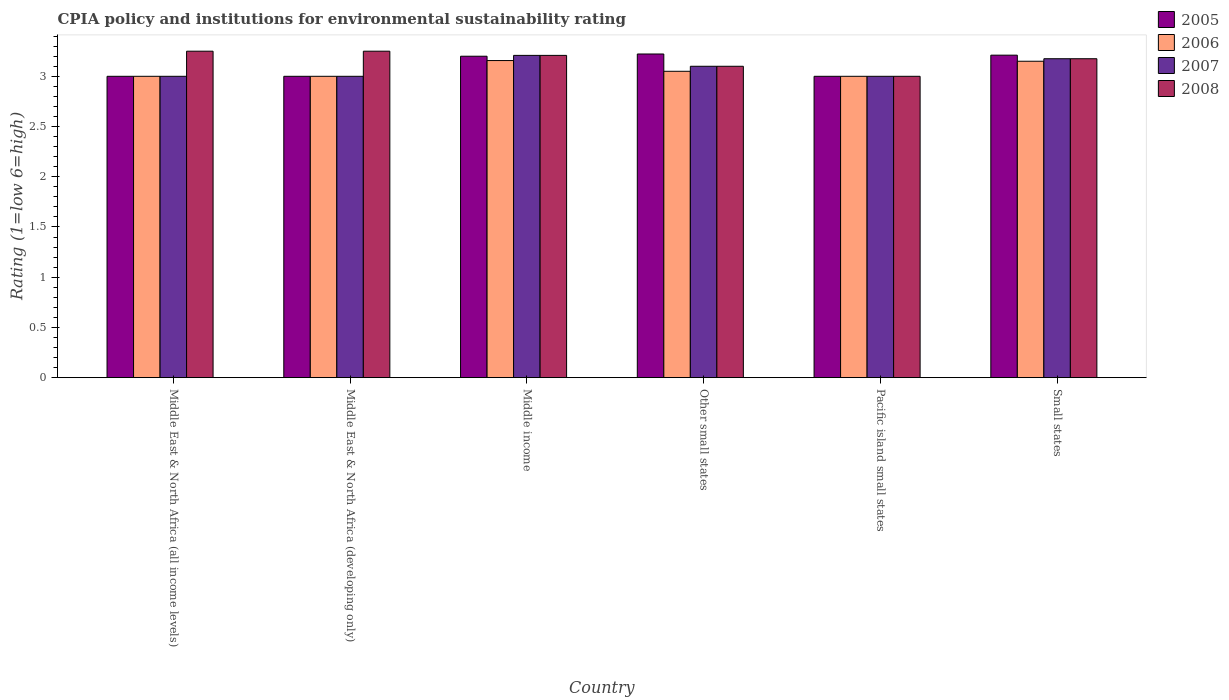Are the number of bars per tick equal to the number of legend labels?
Make the answer very short. Yes. How many bars are there on the 2nd tick from the left?
Provide a succinct answer. 4. What is the label of the 1st group of bars from the left?
Your response must be concise. Middle East & North Africa (all income levels). In how many cases, is the number of bars for a given country not equal to the number of legend labels?
Your answer should be compact. 0. What is the CPIA rating in 2006 in Pacific island small states?
Your answer should be very brief. 3. Across all countries, what is the maximum CPIA rating in 2006?
Provide a short and direct response. 3.16. Across all countries, what is the minimum CPIA rating in 2006?
Offer a very short reply. 3. In which country was the CPIA rating in 2008 maximum?
Your answer should be compact. Middle East & North Africa (all income levels). In which country was the CPIA rating in 2007 minimum?
Offer a terse response. Middle East & North Africa (all income levels). What is the total CPIA rating in 2005 in the graph?
Give a very brief answer. 18.63. What is the difference between the CPIA rating in 2007 in Middle income and that in Other small states?
Make the answer very short. 0.11. What is the difference between the CPIA rating in 2007 in Other small states and the CPIA rating in 2005 in Small states?
Make the answer very short. -0.11. What is the average CPIA rating in 2006 per country?
Your answer should be compact. 3.06. What is the difference between the CPIA rating of/in 2007 and CPIA rating of/in 2008 in Small states?
Provide a short and direct response. 0. What is the ratio of the CPIA rating in 2008 in Middle East & North Africa (developing only) to that in Small states?
Provide a short and direct response. 1.02. Is the CPIA rating in 2008 in Middle East & North Africa (developing only) less than that in Middle income?
Provide a short and direct response. No. Is the difference between the CPIA rating in 2007 in Middle East & North Africa (all income levels) and Middle income greater than the difference between the CPIA rating in 2008 in Middle East & North Africa (all income levels) and Middle income?
Give a very brief answer. No. What is the difference between the highest and the second highest CPIA rating in 2006?
Your answer should be compact. -0.01. What is the difference between the highest and the lowest CPIA rating in 2007?
Keep it short and to the point. 0.21. In how many countries, is the CPIA rating in 2007 greater than the average CPIA rating in 2007 taken over all countries?
Your answer should be very brief. 3. Does the graph contain grids?
Give a very brief answer. No. Where does the legend appear in the graph?
Keep it short and to the point. Top right. How many legend labels are there?
Offer a very short reply. 4. What is the title of the graph?
Give a very brief answer. CPIA policy and institutions for environmental sustainability rating. Does "2001" appear as one of the legend labels in the graph?
Give a very brief answer. No. What is the label or title of the Y-axis?
Your response must be concise. Rating (1=low 6=high). What is the Rating (1=low 6=high) in 2007 in Middle East & North Africa (all income levels)?
Give a very brief answer. 3. What is the Rating (1=low 6=high) in 2008 in Middle East & North Africa (all income levels)?
Provide a succinct answer. 3.25. What is the Rating (1=low 6=high) in 2007 in Middle East & North Africa (developing only)?
Offer a terse response. 3. What is the Rating (1=low 6=high) in 2008 in Middle East & North Africa (developing only)?
Make the answer very short. 3.25. What is the Rating (1=low 6=high) of 2006 in Middle income?
Provide a succinct answer. 3.16. What is the Rating (1=low 6=high) in 2007 in Middle income?
Make the answer very short. 3.21. What is the Rating (1=low 6=high) in 2008 in Middle income?
Ensure brevity in your answer.  3.21. What is the Rating (1=low 6=high) in 2005 in Other small states?
Your response must be concise. 3.22. What is the Rating (1=low 6=high) in 2006 in Other small states?
Offer a very short reply. 3.05. What is the Rating (1=low 6=high) of 2007 in Other small states?
Ensure brevity in your answer.  3.1. What is the Rating (1=low 6=high) of 2008 in Other small states?
Your answer should be very brief. 3.1. What is the Rating (1=low 6=high) of 2005 in Pacific island small states?
Offer a terse response. 3. What is the Rating (1=low 6=high) in 2008 in Pacific island small states?
Offer a terse response. 3. What is the Rating (1=low 6=high) in 2005 in Small states?
Provide a short and direct response. 3.21. What is the Rating (1=low 6=high) of 2006 in Small states?
Keep it short and to the point. 3.15. What is the Rating (1=low 6=high) in 2007 in Small states?
Offer a very short reply. 3.17. What is the Rating (1=low 6=high) of 2008 in Small states?
Your response must be concise. 3.17. Across all countries, what is the maximum Rating (1=low 6=high) of 2005?
Give a very brief answer. 3.22. Across all countries, what is the maximum Rating (1=low 6=high) of 2006?
Your answer should be very brief. 3.16. Across all countries, what is the maximum Rating (1=low 6=high) of 2007?
Offer a terse response. 3.21. Across all countries, what is the minimum Rating (1=low 6=high) in 2005?
Ensure brevity in your answer.  3. Across all countries, what is the minimum Rating (1=low 6=high) of 2006?
Your answer should be very brief. 3. What is the total Rating (1=low 6=high) of 2005 in the graph?
Make the answer very short. 18.63. What is the total Rating (1=low 6=high) in 2006 in the graph?
Your answer should be compact. 18.36. What is the total Rating (1=low 6=high) of 2007 in the graph?
Your answer should be compact. 18.48. What is the total Rating (1=low 6=high) in 2008 in the graph?
Offer a terse response. 18.98. What is the difference between the Rating (1=low 6=high) of 2006 in Middle East & North Africa (all income levels) and that in Middle East & North Africa (developing only)?
Offer a terse response. 0. What is the difference between the Rating (1=low 6=high) in 2007 in Middle East & North Africa (all income levels) and that in Middle East & North Africa (developing only)?
Your answer should be compact. 0. What is the difference between the Rating (1=low 6=high) in 2006 in Middle East & North Africa (all income levels) and that in Middle income?
Offer a terse response. -0.16. What is the difference between the Rating (1=low 6=high) in 2007 in Middle East & North Africa (all income levels) and that in Middle income?
Ensure brevity in your answer.  -0.21. What is the difference between the Rating (1=low 6=high) in 2008 in Middle East & North Africa (all income levels) and that in Middle income?
Offer a terse response. 0.04. What is the difference between the Rating (1=low 6=high) in 2005 in Middle East & North Africa (all income levels) and that in Other small states?
Provide a short and direct response. -0.22. What is the difference between the Rating (1=low 6=high) in 2007 in Middle East & North Africa (all income levels) and that in Other small states?
Give a very brief answer. -0.1. What is the difference between the Rating (1=low 6=high) in 2007 in Middle East & North Africa (all income levels) and that in Pacific island small states?
Provide a succinct answer. 0. What is the difference between the Rating (1=low 6=high) in 2005 in Middle East & North Africa (all income levels) and that in Small states?
Your response must be concise. -0.21. What is the difference between the Rating (1=low 6=high) in 2007 in Middle East & North Africa (all income levels) and that in Small states?
Offer a terse response. -0.17. What is the difference between the Rating (1=low 6=high) of 2008 in Middle East & North Africa (all income levels) and that in Small states?
Give a very brief answer. 0.07. What is the difference between the Rating (1=low 6=high) of 2005 in Middle East & North Africa (developing only) and that in Middle income?
Your response must be concise. -0.2. What is the difference between the Rating (1=low 6=high) of 2006 in Middle East & North Africa (developing only) and that in Middle income?
Keep it short and to the point. -0.16. What is the difference between the Rating (1=low 6=high) in 2007 in Middle East & North Africa (developing only) and that in Middle income?
Ensure brevity in your answer.  -0.21. What is the difference between the Rating (1=low 6=high) of 2008 in Middle East & North Africa (developing only) and that in Middle income?
Offer a terse response. 0.04. What is the difference between the Rating (1=low 6=high) of 2005 in Middle East & North Africa (developing only) and that in Other small states?
Your answer should be very brief. -0.22. What is the difference between the Rating (1=low 6=high) of 2005 in Middle East & North Africa (developing only) and that in Pacific island small states?
Ensure brevity in your answer.  0. What is the difference between the Rating (1=low 6=high) of 2007 in Middle East & North Africa (developing only) and that in Pacific island small states?
Provide a succinct answer. 0. What is the difference between the Rating (1=low 6=high) of 2005 in Middle East & North Africa (developing only) and that in Small states?
Your response must be concise. -0.21. What is the difference between the Rating (1=low 6=high) in 2007 in Middle East & North Africa (developing only) and that in Small states?
Ensure brevity in your answer.  -0.17. What is the difference between the Rating (1=low 6=high) in 2008 in Middle East & North Africa (developing only) and that in Small states?
Provide a succinct answer. 0.07. What is the difference between the Rating (1=low 6=high) in 2005 in Middle income and that in Other small states?
Ensure brevity in your answer.  -0.02. What is the difference between the Rating (1=low 6=high) of 2006 in Middle income and that in Other small states?
Provide a short and direct response. 0.11. What is the difference between the Rating (1=low 6=high) of 2007 in Middle income and that in Other small states?
Offer a very short reply. 0.11. What is the difference between the Rating (1=low 6=high) of 2008 in Middle income and that in Other small states?
Your response must be concise. 0.11. What is the difference between the Rating (1=low 6=high) of 2005 in Middle income and that in Pacific island small states?
Provide a short and direct response. 0.2. What is the difference between the Rating (1=low 6=high) of 2006 in Middle income and that in Pacific island small states?
Provide a short and direct response. 0.16. What is the difference between the Rating (1=low 6=high) in 2007 in Middle income and that in Pacific island small states?
Provide a short and direct response. 0.21. What is the difference between the Rating (1=low 6=high) of 2008 in Middle income and that in Pacific island small states?
Your answer should be very brief. 0.21. What is the difference between the Rating (1=low 6=high) in 2005 in Middle income and that in Small states?
Give a very brief answer. -0.01. What is the difference between the Rating (1=low 6=high) of 2006 in Middle income and that in Small states?
Provide a succinct answer. 0.01. What is the difference between the Rating (1=low 6=high) of 2007 in Middle income and that in Small states?
Keep it short and to the point. 0.03. What is the difference between the Rating (1=low 6=high) in 2008 in Middle income and that in Small states?
Provide a succinct answer. 0.03. What is the difference between the Rating (1=low 6=high) of 2005 in Other small states and that in Pacific island small states?
Make the answer very short. 0.22. What is the difference between the Rating (1=low 6=high) of 2006 in Other small states and that in Pacific island small states?
Provide a short and direct response. 0.05. What is the difference between the Rating (1=low 6=high) of 2005 in Other small states and that in Small states?
Give a very brief answer. 0.01. What is the difference between the Rating (1=low 6=high) in 2007 in Other small states and that in Small states?
Make the answer very short. -0.07. What is the difference between the Rating (1=low 6=high) in 2008 in Other small states and that in Small states?
Offer a very short reply. -0.07. What is the difference between the Rating (1=low 6=high) in 2005 in Pacific island small states and that in Small states?
Offer a very short reply. -0.21. What is the difference between the Rating (1=low 6=high) of 2007 in Pacific island small states and that in Small states?
Offer a very short reply. -0.17. What is the difference between the Rating (1=low 6=high) in 2008 in Pacific island small states and that in Small states?
Keep it short and to the point. -0.17. What is the difference between the Rating (1=low 6=high) in 2005 in Middle East & North Africa (all income levels) and the Rating (1=low 6=high) in 2007 in Middle East & North Africa (developing only)?
Give a very brief answer. 0. What is the difference between the Rating (1=low 6=high) in 2005 in Middle East & North Africa (all income levels) and the Rating (1=low 6=high) in 2008 in Middle East & North Africa (developing only)?
Make the answer very short. -0.25. What is the difference between the Rating (1=low 6=high) in 2006 in Middle East & North Africa (all income levels) and the Rating (1=low 6=high) in 2008 in Middle East & North Africa (developing only)?
Give a very brief answer. -0.25. What is the difference between the Rating (1=low 6=high) in 2005 in Middle East & North Africa (all income levels) and the Rating (1=low 6=high) in 2006 in Middle income?
Ensure brevity in your answer.  -0.16. What is the difference between the Rating (1=low 6=high) in 2005 in Middle East & North Africa (all income levels) and the Rating (1=low 6=high) in 2007 in Middle income?
Provide a succinct answer. -0.21. What is the difference between the Rating (1=low 6=high) of 2005 in Middle East & North Africa (all income levels) and the Rating (1=low 6=high) of 2008 in Middle income?
Your answer should be compact. -0.21. What is the difference between the Rating (1=low 6=high) of 2006 in Middle East & North Africa (all income levels) and the Rating (1=low 6=high) of 2007 in Middle income?
Make the answer very short. -0.21. What is the difference between the Rating (1=low 6=high) of 2006 in Middle East & North Africa (all income levels) and the Rating (1=low 6=high) of 2008 in Middle income?
Offer a very short reply. -0.21. What is the difference between the Rating (1=low 6=high) in 2007 in Middle East & North Africa (all income levels) and the Rating (1=low 6=high) in 2008 in Middle income?
Provide a succinct answer. -0.21. What is the difference between the Rating (1=low 6=high) of 2005 in Middle East & North Africa (all income levels) and the Rating (1=low 6=high) of 2006 in Other small states?
Your answer should be very brief. -0.05. What is the difference between the Rating (1=low 6=high) of 2005 in Middle East & North Africa (all income levels) and the Rating (1=low 6=high) of 2007 in Other small states?
Your response must be concise. -0.1. What is the difference between the Rating (1=low 6=high) in 2006 in Middle East & North Africa (all income levels) and the Rating (1=low 6=high) in 2007 in Other small states?
Ensure brevity in your answer.  -0.1. What is the difference between the Rating (1=low 6=high) of 2005 in Middle East & North Africa (all income levels) and the Rating (1=low 6=high) of 2008 in Pacific island small states?
Provide a succinct answer. 0. What is the difference between the Rating (1=low 6=high) in 2006 in Middle East & North Africa (all income levels) and the Rating (1=low 6=high) in 2007 in Pacific island small states?
Offer a very short reply. 0. What is the difference between the Rating (1=low 6=high) of 2006 in Middle East & North Africa (all income levels) and the Rating (1=low 6=high) of 2008 in Pacific island small states?
Keep it short and to the point. 0. What is the difference between the Rating (1=low 6=high) in 2007 in Middle East & North Africa (all income levels) and the Rating (1=low 6=high) in 2008 in Pacific island small states?
Offer a terse response. 0. What is the difference between the Rating (1=low 6=high) of 2005 in Middle East & North Africa (all income levels) and the Rating (1=low 6=high) of 2007 in Small states?
Provide a succinct answer. -0.17. What is the difference between the Rating (1=low 6=high) in 2005 in Middle East & North Africa (all income levels) and the Rating (1=low 6=high) in 2008 in Small states?
Provide a succinct answer. -0.17. What is the difference between the Rating (1=low 6=high) in 2006 in Middle East & North Africa (all income levels) and the Rating (1=low 6=high) in 2007 in Small states?
Your answer should be very brief. -0.17. What is the difference between the Rating (1=low 6=high) of 2006 in Middle East & North Africa (all income levels) and the Rating (1=low 6=high) of 2008 in Small states?
Make the answer very short. -0.17. What is the difference between the Rating (1=low 6=high) in 2007 in Middle East & North Africa (all income levels) and the Rating (1=low 6=high) in 2008 in Small states?
Ensure brevity in your answer.  -0.17. What is the difference between the Rating (1=low 6=high) in 2005 in Middle East & North Africa (developing only) and the Rating (1=low 6=high) in 2006 in Middle income?
Offer a very short reply. -0.16. What is the difference between the Rating (1=low 6=high) in 2005 in Middle East & North Africa (developing only) and the Rating (1=low 6=high) in 2007 in Middle income?
Offer a very short reply. -0.21. What is the difference between the Rating (1=low 6=high) in 2005 in Middle East & North Africa (developing only) and the Rating (1=low 6=high) in 2008 in Middle income?
Give a very brief answer. -0.21. What is the difference between the Rating (1=low 6=high) of 2006 in Middle East & North Africa (developing only) and the Rating (1=low 6=high) of 2007 in Middle income?
Offer a very short reply. -0.21. What is the difference between the Rating (1=low 6=high) in 2006 in Middle East & North Africa (developing only) and the Rating (1=low 6=high) in 2008 in Middle income?
Give a very brief answer. -0.21. What is the difference between the Rating (1=low 6=high) of 2007 in Middle East & North Africa (developing only) and the Rating (1=low 6=high) of 2008 in Middle income?
Keep it short and to the point. -0.21. What is the difference between the Rating (1=low 6=high) in 2005 in Middle East & North Africa (developing only) and the Rating (1=low 6=high) in 2007 in Other small states?
Your answer should be very brief. -0.1. What is the difference between the Rating (1=low 6=high) in 2006 in Middle East & North Africa (developing only) and the Rating (1=low 6=high) in 2008 in Other small states?
Make the answer very short. -0.1. What is the difference between the Rating (1=low 6=high) of 2007 in Middle East & North Africa (developing only) and the Rating (1=low 6=high) of 2008 in Other small states?
Your response must be concise. -0.1. What is the difference between the Rating (1=low 6=high) in 2005 in Middle East & North Africa (developing only) and the Rating (1=low 6=high) in 2007 in Pacific island small states?
Your answer should be very brief. 0. What is the difference between the Rating (1=low 6=high) of 2005 in Middle East & North Africa (developing only) and the Rating (1=low 6=high) of 2008 in Pacific island small states?
Provide a succinct answer. 0. What is the difference between the Rating (1=low 6=high) in 2006 in Middle East & North Africa (developing only) and the Rating (1=low 6=high) in 2007 in Pacific island small states?
Provide a short and direct response. 0. What is the difference between the Rating (1=low 6=high) of 2005 in Middle East & North Africa (developing only) and the Rating (1=low 6=high) of 2007 in Small states?
Provide a short and direct response. -0.17. What is the difference between the Rating (1=low 6=high) of 2005 in Middle East & North Africa (developing only) and the Rating (1=low 6=high) of 2008 in Small states?
Offer a terse response. -0.17. What is the difference between the Rating (1=low 6=high) in 2006 in Middle East & North Africa (developing only) and the Rating (1=low 6=high) in 2007 in Small states?
Provide a succinct answer. -0.17. What is the difference between the Rating (1=low 6=high) in 2006 in Middle East & North Africa (developing only) and the Rating (1=low 6=high) in 2008 in Small states?
Provide a succinct answer. -0.17. What is the difference between the Rating (1=low 6=high) in 2007 in Middle East & North Africa (developing only) and the Rating (1=low 6=high) in 2008 in Small states?
Make the answer very short. -0.17. What is the difference between the Rating (1=low 6=high) in 2005 in Middle income and the Rating (1=low 6=high) in 2008 in Other small states?
Your answer should be compact. 0.1. What is the difference between the Rating (1=low 6=high) in 2006 in Middle income and the Rating (1=low 6=high) in 2007 in Other small states?
Your answer should be compact. 0.06. What is the difference between the Rating (1=low 6=high) of 2006 in Middle income and the Rating (1=low 6=high) of 2008 in Other small states?
Your response must be concise. 0.06. What is the difference between the Rating (1=low 6=high) of 2007 in Middle income and the Rating (1=low 6=high) of 2008 in Other small states?
Provide a short and direct response. 0.11. What is the difference between the Rating (1=low 6=high) of 2005 in Middle income and the Rating (1=low 6=high) of 2007 in Pacific island small states?
Provide a short and direct response. 0.2. What is the difference between the Rating (1=low 6=high) of 2006 in Middle income and the Rating (1=low 6=high) of 2007 in Pacific island small states?
Give a very brief answer. 0.16. What is the difference between the Rating (1=low 6=high) of 2006 in Middle income and the Rating (1=low 6=high) of 2008 in Pacific island small states?
Your answer should be compact. 0.16. What is the difference between the Rating (1=low 6=high) of 2007 in Middle income and the Rating (1=low 6=high) of 2008 in Pacific island small states?
Provide a short and direct response. 0.21. What is the difference between the Rating (1=low 6=high) in 2005 in Middle income and the Rating (1=low 6=high) in 2007 in Small states?
Your response must be concise. 0.03. What is the difference between the Rating (1=low 6=high) in 2005 in Middle income and the Rating (1=low 6=high) in 2008 in Small states?
Give a very brief answer. 0.03. What is the difference between the Rating (1=low 6=high) in 2006 in Middle income and the Rating (1=low 6=high) in 2007 in Small states?
Your answer should be very brief. -0.02. What is the difference between the Rating (1=low 6=high) in 2006 in Middle income and the Rating (1=low 6=high) in 2008 in Small states?
Make the answer very short. -0.02. What is the difference between the Rating (1=low 6=high) in 2005 in Other small states and the Rating (1=low 6=high) in 2006 in Pacific island small states?
Offer a terse response. 0.22. What is the difference between the Rating (1=low 6=high) in 2005 in Other small states and the Rating (1=low 6=high) in 2007 in Pacific island small states?
Give a very brief answer. 0.22. What is the difference between the Rating (1=low 6=high) in 2005 in Other small states and the Rating (1=low 6=high) in 2008 in Pacific island small states?
Offer a terse response. 0.22. What is the difference between the Rating (1=low 6=high) in 2005 in Other small states and the Rating (1=low 6=high) in 2006 in Small states?
Ensure brevity in your answer.  0.07. What is the difference between the Rating (1=low 6=high) in 2005 in Other small states and the Rating (1=low 6=high) in 2007 in Small states?
Ensure brevity in your answer.  0.05. What is the difference between the Rating (1=low 6=high) of 2005 in Other small states and the Rating (1=low 6=high) of 2008 in Small states?
Your answer should be very brief. 0.05. What is the difference between the Rating (1=low 6=high) in 2006 in Other small states and the Rating (1=low 6=high) in 2007 in Small states?
Offer a very short reply. -0.12. What is the difference between the Rating (1=low 6=high) of 2006 in Other small states and the Rating (1=low 6=high) of 2008 in Small states?
Offer a terse response. -0.12. What is the difference between the Rating (1=low 6=high) in 2007 in Other small states and the Rating (1=low 6=high) in 2008 in Small states?
Keep it short and to the point. -0.07. What is the difference between the Rating (1=low 6=high) of 2005 in Pacific island small states and the Rating (1=low 6=high) of 2006 in Small states?
Your response must be concise. -0.15. What is the difference between the Rating (1=low 6=high) of 2005 in Pacific island small states and the Rating (1=low 6=high) of 2007 in Small states?
Offer a very short reply. -0.17. What is the difference between the Rating (1=low 6=high) in 2005 in Pacific island small states and the Rating (1=low 6=high) in 2008 in Small states?
Make the answer very short. -0.17. What is the difference between the Rating (1=low 6=high) in 2006 in Pacific island small states and the Rating (1=low 6=high) in 2007 in Small states?
Your answer should be compact. -0.17. What is the difference between the Rating (1=low 6=high) in 2006 in Pacific island small states and the Rating (1=low 6=high) in 2008 in Small states?
Your answer should be very brief. -0.17. What is the difference between the Rating (1=low 6=high) in 2007 in Pacific island small states and the Rating (1=low 6=high) in 2008 in Small states?
Offer a very short reply. -0.17. What is the average Rating (1=low 6=high) in 2005 per country?
Make the answer very short. 3.11. What is the average Rating (1=low 6=high) of 2006 per country?
Offer a very short reply. 3.06. What is the average Rating (1=low 6=high) of 2007 per country?
Keep it short and to the point. 3.08. What is the average Rating (1=low 6=high) in 2008 per country?
Make the answer very short. 3.16. What is the difference between the Rating (1=low 6=high) of 2005 and Rating (1=low 6=high) of 2006 in Middle East & North Africa (all income levels)?
Keep it short and to the point. 0. What is the difference between the Rating (1=low 6=high) in 2005 and Rating (1=low 6=high) in 2008 in Middle East & North Africa (all income levels)?
Keep it short and to the point. -0.25. What is the difference between the Rating (1=low 6=high) in 2006 and Rating (1=low 6=high) in 2008 in Middle East & North Africa (all income levels)?
Your answer should be very brief. -0.25. What is the difference between the Rating (1=low 6=high) of 2005 and Rating (1=low 6=high) of 2006 in Middle East & North Africa (developing only)?
Your response must be concise. 0. What is the difference between the Rating (1=low 6=high) in 2006 and Rating (1=low 6=high) in 2007 in Middle East & North Africa (developing only)?
Offer a very short reply. 0. What is the difference between the Rating (1=low 6=high) of 2005 and Rating (1=low 6=high) of 2006 in Middle income?
Offer a terse response. 0.04. What is the difference between the Rating (1=low 6=high) in 2005 and Rating (1=low 6=high) in 2007 in Middle income?
Offer a terse response. -0.01. What is the difference between the Rating (1=low 6=high) in 2005 and Rating (1=low 6=high) in 2008 in Middle income?
Your answer should be compact. -0.01. What is the difference between the Rating (1=low 6=high) of 2006 and Rating (1=low 6=high) of 2007 in Middle income?
Your response must be concise. -0.05. What is the difference between the Rating (1=low 6=high) of 2006 and Rating (1=low 6=high) of 2008 in Middle income?
Provide a short and direct response. -0.05. What is the difference between the Rating (1=low 6=high) of 2007 and Rating (1=low 6=high) of 2008 in Middle income?
Keep it short and to the point. 0. What is the difference between the Rating (1=low 6=high) in 2005 and Rating (1=low 6=high) in 2006 in Other small states?
Offer a terse response. 0.17. What is the difference between the Rating (1=low 6=high) of 2005 and Rating (1=low 6=high) of 2007 in Other small states?
Offer a terse response. 0.12. What is the difference between the Rating (1=low 6=high) in 2005 and Rating (1=low 6=high) in 2008 in Other small states?
Make the answer very short. 0.12. What is the difference between the Rating (1=low 6=high) in 2006 and Rating (1=low 6=high) in 2007 in Other small states?
Give a very brief answer. -0.05. What is the difference between the Rating (1=low 6=high) of 2005 and Rating (1=low 6=high) of 2006 in Pacific island small states?
Provide a short and direct response. 0. What is the difference between the Rating (1=low 6=high) of 2005 and Rating (1=low 6=high) of 2008 in Pacific island small states?
Your response must be concise. 0. What is the difference between the Rating (1=low 6=high) in 2005 and Rating (1=low 6=high) in 2006 in Small states?
Your response must be concise. 0.06. What is the difference between the Rating (1=low 6=high) of 2005 and Rating (1=low 6=high) of 2007 in Small states?
Provide a short and direct response. 0.04. What is the difference between the Rating (1=low 6=high) in 2005 and Rating (1=low 6=high) in 2008 in Small states?
Keep it short and to the point. 0.04. What is the difference between the Rating (1=low 6=high) of 2006 and Rating (1=low 6=high) of 2007 in Small states?
Make the answer very short. -0.03. What is the difference between the Rating (1=low 6=high) in 2006 and Rating (1=low 6=high) in 2008 in Small states?
Your answer should be compact. -0.03. What is the ratio of the Rating (1=low 6=high) of 2007 in Middle East & North Africa (all income levels) to that in Middle East & North Africa (developing only)?
Provide a short and direct response. 1. What is the ratio of the Rating (1=low 6=high) of 2008 in Middle East & North Africa (all income levels) to that in Middle East & North Africa (developing only)?
Provide a short and direct response. 1. What is the ratio of the Rating (1=low 6=high) of 2006 in Middle East & North Africa (all income levels) to that in Middle income?
Provide a succinct answer. 0.95. What is the ratio of the Rating (1=low 6=high) in 2007 in Middle East & North Africa (all income levels) to that in Middle income?
Make the answer very short. 0.94. What is the ratio of the Rating (1=low 6=high) in 2006 in Middle East & North Africa (all income levels) to that in Other small states?
Make the answer very short. 0.98. What is the ratio of the Rating (1=low 6=high) in 2008 in Middle East & North Africa (all income levels) to that in Other small states?
Ensure brevity in your answer.  1.05. What is the ratio of the Rating (1=low 6=high) in 2005 in Middle East & North Africa (all income levels) to that in Pacific island small states?
Your answer should be very brief. 1. What is the ratio of the Rating (1=low 6=high) in 2005 in Middle East & North Africa (all income levels) to that in Small states?
Give a very brief answer. 0.93. What is the ratio of the Rating (1=low 6=high) in 2007 in Middle East & North Africa (all income levels) to that in Small states?
Your answer should be compact. 0.94. What is the ratio of the Rating (1=low 6=high) in 2008 in Middle East & North Africa (all income levels) to that in Small states?
Your answer should be compact. 1.02. What is the ratio of the Rating (1=low 6=high) in 2005 in Middle East & North Africa (developing only) to that in Middle income?
Offer a terse response. 0.94. What is the ratio of the Rating (1=low 6=high) of 2006 in Middle East & North Africa (developing only) to that in Middle income?
Your answer should be compact. 0.95. What is the ratio of the Rating (1=low 6=high) of 2007 in Middle East & North Africa (developing only) to that in Middle income?
Your response must be concise. 0.94. What is the ratio of the Rating (1=low 6=high) of 2005 in Middle East & North Africa (developing only) to that in Other small states?
Offer a terse response. 0.93. What is the ratio of the Rating (1=low 6=high) in 2006 in Middle East & North Africa (developing only) to that in Other small states?
Offer a very short reply. 0.98. What is the ratio of the Rating (1=low 6=high) of 2008 in Middle East & North Africa (developing only) to that in Other small states?
Your response must be concise. 1.05. What is the ratio of the Rating (1=low 6=high) in 2005 in Middle East & North Africa (developing only) to that in Small states?
Your answer should be very brief. 0.93. What is the ratio of the Rating (1=low 6=high) of 2007 in Middle East & North Africa (developing only) to that in Small states?
Your response must be concise. 0.94. What is the ratio of the Rating (1=low 6=high) of 2008 in Middle East & North Africa (developing only) to that in Small states?
Keep it short and to the point. 1.02. What is the ratio of the Rating (1=low 6=high) in 2006 in Middle income to that in Other small states?
Keep it short and to the point. 1.03. What is the ratio of the Rating (1=low 6=high) in 2007 in Middle income to that in Other small states?
Your answer should be compact. 1.03. What is the ratio of the Rating (1=low 6=high) in 2008 in Middle income to that in Other small states?
Offer a terse response. 1.03. What is the ratio of the Rating (1=low 6=high) of 2005 in Middle income to that in Pacific island small states?
Provide a succinct answer. 1.07. What is the ratio of the Rating (1=low 6=high) in 2006 in Middle income to that in Pacific island small states?
Provide a short and direct response. 1.05. What is the ratio of the Rating (1=low 6=high) in 2007 in Middle income to that in Pacific island small states?
Offer a very short reply. 1.07. What is the ratio of the Rating (1=low 6=high) in 2008 in Middle income to that in Pacific island small states?
Provide a succinct answer. 1.07. What is the ratio of the Rating (1=low 6=high) in 2007 in Middle income to that in Small states?
Offer a very short reply. 1.01. What is the ratio of the Rating (1=low 6=high) of 2008 in Middle income to that in Small states?
Your answer should be very brief. 1.01. What is the ratio of the Rating (1=low 6=high) in 2005 in Other small states to that in Pacific island small states?
Your response must be concise. 1.07. What is the ratio of the Rating (1=low 6=high) in 2006 in Other small states to that in Pacific island small states?
Ensure brevity in your answer.  1.02. What is the ratio of the Rating (1=low 6=high) of 2006 in Other small states to that in Small states?
Offer a very short reply. 0.97. What is the ratio of the Rating (1=low 6=high) in 2007 in Other small states to that in Small states?
Your answer should be very brief. 0.98. What is the ratio of the Rating (1=low 6=high) of 2008 in Other small states to that in Small states?
Your response must be concise. 0.98. What is the ratio of the Rating (1=low 6=high) in 2005 in Pacific island small states to that in Small states?
Give a very brief answer. 0.93. What is the ratio of the Rating (1=low 6=high) of 2006 in Pacific island small states to that in Small states?
Your response must be concise. 0.95. What is the ratio of the Rating (1=low 6=high) in 2007 in Pacific island small states to that in Small states?
Your response must be concise. 0.94. What is the ratio of the Rating (1=low 6=high) in 2008 in Pacific island small states to that in Small states?
Make the answer very short. 0.94. What is the difference between the highest and the second highest Rating (1=low 6=high) of 2005?
Provide a short and direct response. 0.01. What is the difference between the highest and the second highest Rating (1=low 6=high) of 2006?
Provide a short and direct response. 0.01. What is the difference between the highest and the second highest Rating (1=low 6=high) in 2007?
Offer a very short reply. 0.03. What is the difference between the highest and the lowest Rating (1=low 6=high) in 2005?
Make the answer very short. 0.22. What is the difference between the highest and the lowest Rating (1=low 6=high) in 2006?
Make the answer very short. 0.16. What is the difference between the highest and the lowest Rating (1=low 6=high) of 2007?
Your response must be concise. 0.21. What is the difference between the highest and the lowest Rating (1=low 6=high) of 2008?
Offer a terse response. 0.25. 